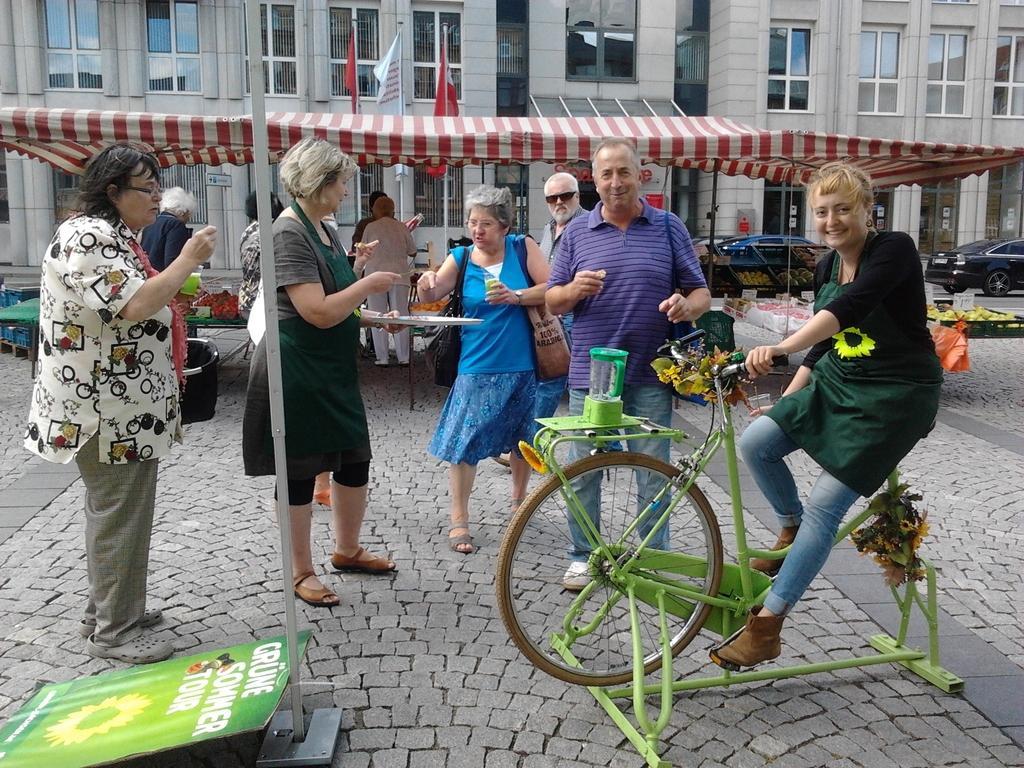Could you give a brief overview of what you see in this image? These persons are standing and this person sitting and holding bicycle,this person wear bags,this person holding tray. On the background we can see building,glass windows,tent,flags,fruits,baskets,tables,vehicles on the road. 